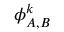Convert formula to latex. <formula><loc_0><loc_0><loc_500><loc_500>{ \phi } _ { A , B } ^ { k }</formula> 